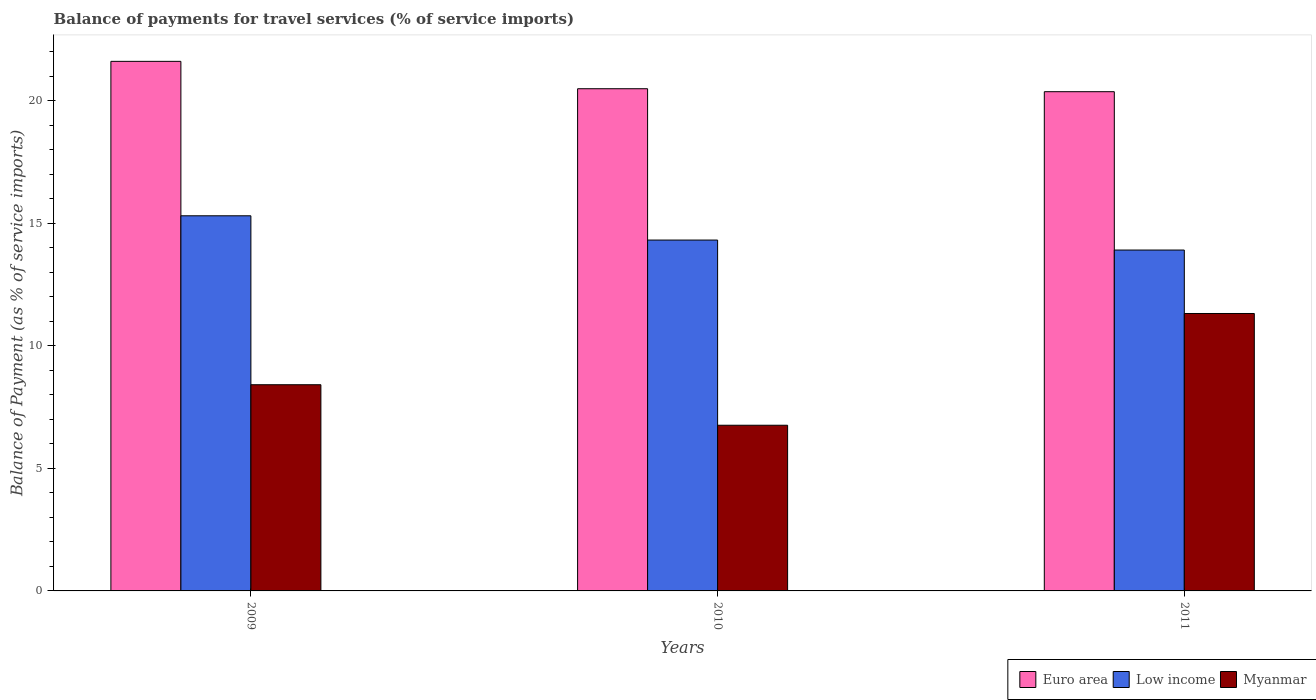How many different coloured bars are there?
Provide a short and direct response. 3. How many groups of bars are there?
Your answer should be very brief. 3. Are the number of bars per tick equal to the number of legend labels?
Your answer should be very brief. Yes. How many bars are there on the 1st tick from the left?
Your answer should be compact. 3. In how many cases, is the number of bars for a given year not equal to the number of legend labels?
Offer a very short reply. 0. What is the balance of payments for travel services in Low income in 2009?
Provide a short and direct response. 15.3. Across all years, what is the maximum balance of payments for travel services in Myanmar?
Your answer should be very brief. 11.32. Across all years, what is the minimum balance of payments for travel services in Myanmar?
Offer a very short reply. 6.76. What is the total balance of payments for travel services in Low income in the graph?
Offer a terse response. 43.52. What is the difference between the balance of payments for travel services in Euro area in 2010 and that in 2011?
Your answer should be very brief. 0.12. What is the difference between the balance of payments for travel services in Myanmar in 2011 and the balance of payments for travel services in Low income in 2010?
Offer a very short reply. -3. What is the average balance of payments for travel services in Low income per year?
Give a very brief answer. 14.51. In the year 2011, what is the difference between the balance of payments for travel services in Myanmar and balance of payments for travel services in Low income?
Offer a very short reply. -2.59. What is the ratio of the balance of payments for travel services in Euro area in 2010 to that in 2011?
Give a very brief answer. 1.01. What is the difference between the highest and the second highest balance of payments for travel services in Low income?
Offer a terse response. 0.99. What is the difference between the highest and the lowest balance of payments for travel services in Euro area?
Your answer should be very brief. 1.24. Is the sum of the balance of payments for travel services in Myanmar in 2009 and 2011 greater than the maximum balance of payments for travel services in Low income across all years?
Offer a terse response. Yes. What does the 2nd bar from the left in 2010 represents?
Offer a terse response. Low income. What does the 3rd bar from the right in 2010 represents?
Your answer should be compact. Euro area. What is the difference between two consecutive major ticks on the Y-axis?
Keep it short and to the point. 5. Are the values on the major ticks of Y-axis written in scientific E-notation?
Your response must be concise. No. How are the legend labels stacked?
Offer a terse response. Horizontal. What is the title of the graph?
Offer a very short reply. Balance of payments for travel services (% of service imports). Does "Switzerland" appear as one of the legend labels in the graph?
Ensure brevity in your answer.  No. What is the label or title of the X-axis?
Offer a terse response. Years. What is the label or title of the Y-axis?
Provide a short and direct response. Balance of Payment (as % of service imports). What is the Balance of Payment (as % of service imports) of Euro area in 2009?
Your answer should be compact. 21.6. What is the Balance of Payment (as % of service imports) of Low income in 2009?
Your answer should be very brief. 15.3. What is the Balance of Payment (as % of service imports) of Myanmar in 2009?
Offer a very short reply. 8.41. What is the Balance of Payment (as % of service imports) of Euro area in 2010?
Provide a short and direct response. 20.48. What is the Balance of Payment (as % of service imports) in Low income in 2010?
Your response must be concise. 14.31. What is the Balance of Payment (as % of service imports) in Myanmar in 2010?
Offer a very short reply. 6.76. What is the Balance of Payment (as % of service imports) in Euro area in 2011?
Provide a succinct answer. 20.36. What is the Balance of Payment (as % of service imports) in Low income in 2011?
Provide a succinct answer. 13.9. What is the Balance of Payment (as % of service imports) in Myanmar in 2011?
Your response must be concise. 11.32. Across all years, what is the maximum Balance of Payment (as % of service imports) in Euro area?
Your answer should be very brief. 21.6. Across all years, what is the maximum Balance of Payment (as % of service imports) of Low income?
Your response must be concise. 15.3. Across all years, what is the maximum Balance of Payment (as % of service imports) of Myanmar?
Your answer should be compact. 11.32. Across all years, what is the minimum Balance of Payment (as % of service imports) of Euro area?
Provide a succinct answer. 20.36. Across all years, what is the minimum Balance of Payment (as % of service imports) in Low income?
Give a very brief answer. 13.9. Across all years, what is the minimum Balance of Payment (as % of service imports) in Myanmar?
Make the answer very short. 6.76. What is the total Balance of Payment (as % of service imports) in Euro area in the graph?
Offer a terse response. 62.45. What is the total Balance of Payment (as % of service imports) in Low income in the graph?
Offer a very short reply. 43.52. What is the total Balance of Payment (as % of service imports) of Myanmar in the graph?
Make the answer very short. 26.49. What is the difference between the Balance of Payment (as % of service imports) of Euro area in 2009 and that in 2010?
Your response must be concise. 1.12. What is the difference between the Balance of Payment (as % of service imports) in Low income in 2009 and that in 2010?
Your answer should be very brief. 0.99. What is the difference between the Balance of Payment (as % of service imports) in Myanmar in 2009 and that in 2010?
Provide a succinct answer. 1.65. What is the difference between the Balance of Payment (as % of service imports) in Euro area in 2009 and that in 2011?
Your answer should be very brief. 1.24. What is the difference between the Balance of Payment (as % of service imports) of Low income in 2009 and that in 2011?
Make the answer very short. 1.4. What is the difference between the Balance of Payment (as % of service imports) in Myanmar in 2009 and that in 2011?
Your answer should be compact. -2.91. What is the difference between the Balance of Payment (as % of service imports) of Euro area in 2010 and that in 2011?
Keep it short and to the point. 0.12. What is the difference between the Balance of Payment (as % of service imports) of Low income in 2010 and that in 2011?
Make the answer very short. 0.41. What is the difference between the Balance of Payment (as % of service imports) in Myanmar in 2010 and that in 2011?
Offer a very short reply. -4.56. What is the difference between the Balance of Payment (as % of service imports) of Euro area in 2009 and the Balance of Payment (as % of service imports) of Low income in 2010?
Provide a succinct answer. 7.29. What is the difference between the Balance of Payment (as % of service imports) of Euro area in 2009 and the Balance of Payment (as % of service imports) of Myanmar in 2010?
Make the answer very short. 14.84. What is the difference between the Balance of Payment (as % of service imports) of Low income in 2009 and the Balance of Payment (as % of service imports) of Myanmar in 2010?
Your answer should be very brief. 8.54. What is the difference between the Balance of Payment (as % of service imports) in Euro area in 2009 and the Balance of Payment (as % of service imports) in Low income in 2011?
Give a very brief answer. 7.7. What is the difference between the Balance of Payment (as % of service imports) of Euro area in 2009 and the Balance of Payment (as % of service imports) of Myanmar in 2011?
Offer a very short reply. 10.28. What is the difference between the Balance of Payment (as % of service imports) of Low income in 2009 and the Balance of Payment (as % of service imports) of Myanmar in 2011?
Your answer should be very brief. 3.98. What is the difference between the Balance of Payment (as % of service imports) of Euro area in 2010 and the Balance of Payment (as % of service imports) of Low income in 2011?
Give a very brief answer. 6.58. What is the difference between the Balance of Payment (as % of service imports) of Euro area in 2010 and the Balance of Payment (as % of service imports) of Myanmar in 2011?
Your response must be concise. 9.17. What is the difference between the Balance of Payment (as % of service imports) of Low income in 2010 and the Balance of Payment (as % of service imports) of Myanmar in 2011?
Keep it short and to the point. 3. What is the average Balance of Payment (as % of service imports) of Euro area per year?
Your answer should be compact. 20.82. What is the average Balance of Payment (as % of service imports) of Low income per year?
Provide a short and direct response. 14.51. What is the average Balance of Payment (as % of service imports) in Myanmar per year?
Offer a terse response. 8.83. In the year 2009, what is the difference between the Balance of Payment (as % of service imports) in Euro area and Balance of Payment (as % of service imports) in Low income?
Your answer should be very brief. 6.3. In the year 2009, what is the difference between the Balance of Payment (as % of service imports) in Euro area and Balance of Payment (as % of service imports) in Myanmar?
Keep it short and to the point. 13.19. In the year 2009, what is the difference between the Balance of Payment (as % of service imports) in Low income and Balance of Payment (as % of service imports) in Myanmar?
Give a very brief answer. 6.89. In the year 2010, what is the difference between the Balance of Payment (as % of service imports) in Euro area and Balance of Payment (as % of service imports) in Low income?
Ensure brevity in your answer.  6.17. In the year 2010, what is the difference between the Balance of Payment (as % of service imports) of Euro area and Balance of Payment (as % of service imports) of Myanmar?
Ensure brevity in your answer.  13.73. In the year 2010, what is the difference between the Balance of Payment (as % of service imports) in Low income and Balance of Payment (as % of service imports) in Myanmar?
Ensure brevity in your answer.  7.55. In the year 2011, what is the difference between the Balance of Payment (as % of service imports) of Euro area and Balance of Payment (as % of service imports) of Low income?
Provide a succinct answer. 6.46. In the year 2011, what is the difference between the Balance of Payment (as % of service imports) in Euro area and Balance of Payment (as % of service imports) in Myanmar?
Your answer should be compact. 9.05. In the year 2011, what is the difference between the Balance of Payment (as % of service imports) in Low income and Balance of Payment (as % of service imports) in Myanmar?
Keep it short and to the point. 2.59. What is the ratio of the Balance of Payment (as % of service imports) of Euro area in 2009 to that in 2010?
Ensure brevity in your answer.  1.05. What is the ratio of the Balance of Payment (as % of service imports) in Low income in 2009 to that in 2010?
Provide a short and direct response. 1.07. What is the ratio of the Balance of Payment (as % of service imports) of Myanmar in 2009 to that in 2010?
Offer a very short reply. 1.24. What is the ratio of the Balance of Payment (as % of service imports) of Euro area in 2009 to that in 2011?
Your answer should be compact. 1.06. What is the ratio of the Balance of Payment (as % of service imports) in Low income in 2009 to that in 2011?
Your response must be concise. 1.1. What is the ratio of the Balance of Payment (as % of service imports) of Myanmar in 2009 to that in 2011?
Your response must be concise. 0.74. What is the ratio of the Balance of Payment (as % of service imports) of Euro area in 2010 to that in 2011?
Provide a succinct answer. 1.01. What is the ratio of the Balance of Payment (as % of service imports) of Low income in 2010 to that in 2011?
Ensure brevity in your answer.  1.03. What is the ratio of the Balance of Payment (as % of service imports) in Myanmar in 2010 to that in 2011?
Give a very brief answer. 0.6. What is the difference between the highest and the second highest Balance of Payment (as % of service imports) in Euro area?
Offer a terse response. 1.12. What is the difference between the highest and the second highest Balance of Payment (as % of service imports) of Low income?
Offer a very short reply. 0.99. What is the difference between the highest and the second highest Balance of Payment (as % of service imports) of Myanmar?
Offer a very short reply. 2.91. What is the difference between the highest and the lowest Balance of Payment (as % of service imports) in Euro area?
Keep it short and to the point. 1.24. What is the difference between the highest and the lowest Balance of Payment (as % of service imports) of Low income?
Make the answer very short. 1.4. What is the difference between the highest and the lowest Balance of Payment (as % of service imports) of Myanmar?
Provide a succinct answer. 4.56. 